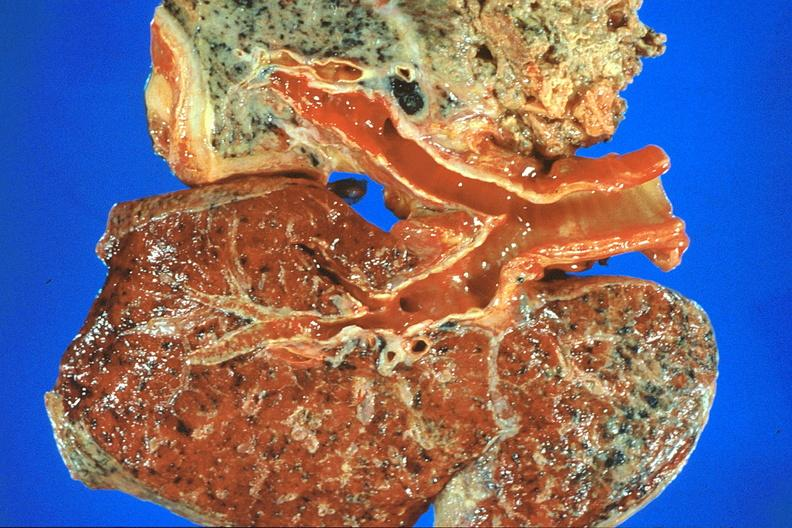does close-up show lung, asbestosis and mesothelioma?
Answer the question using a single word or phrase. No 